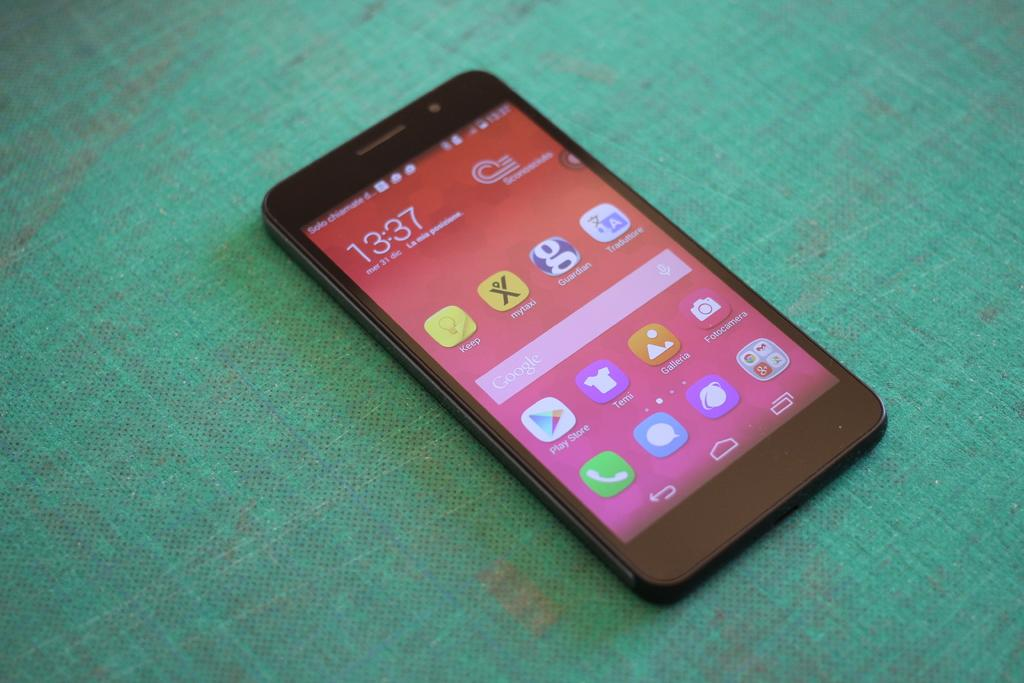<image>
Share a concise interpretation of the image provided. a black smart phone with the screen on and the time on it reading 13:37 